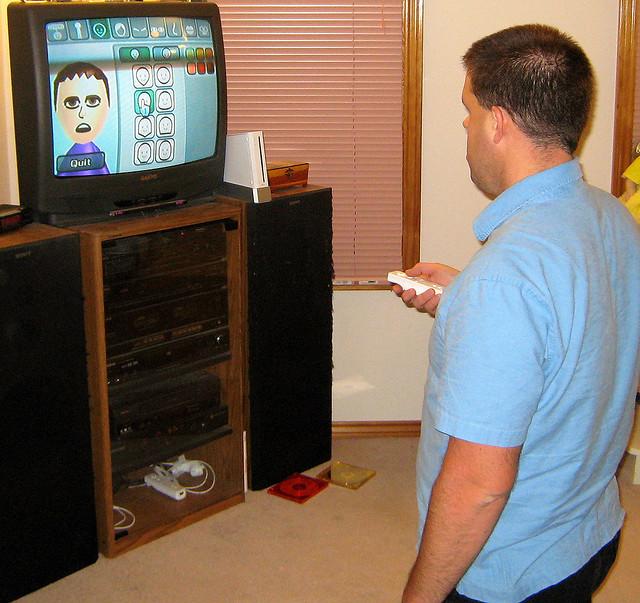What does the man have in his hand?
Give a very brief answer. Wii remote. What game console is that?
Write a very short answer. Wii. What is the man wearing?
Give a very brief answer. Blue shirt. What is the brand of this television?
Be succinct. Sanyo. 